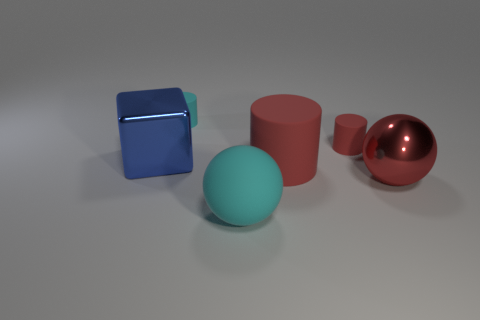Add 2 small red matte cylinders. How many objects exist? 8 Subtract all cubes. How many objects are left? 5 Subtract all large brown objects. Subtract all big red objects. How many objects are left? 4 Add 3 large cubes. How many large cubes are left? 4 Add 6 small yellow metallic blocks. How many small yellow metallic blocks exist? 6 Subtract 1 blue cubes. How many objects are left? 5 